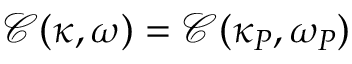<formula> <loc_0><loc_0><loc_500><loc_500>\mathcal { C } ( \kappa , \omega ) = \mathcal { C } ( \kappa _ { P } , \omega _ { P } )</formula> 